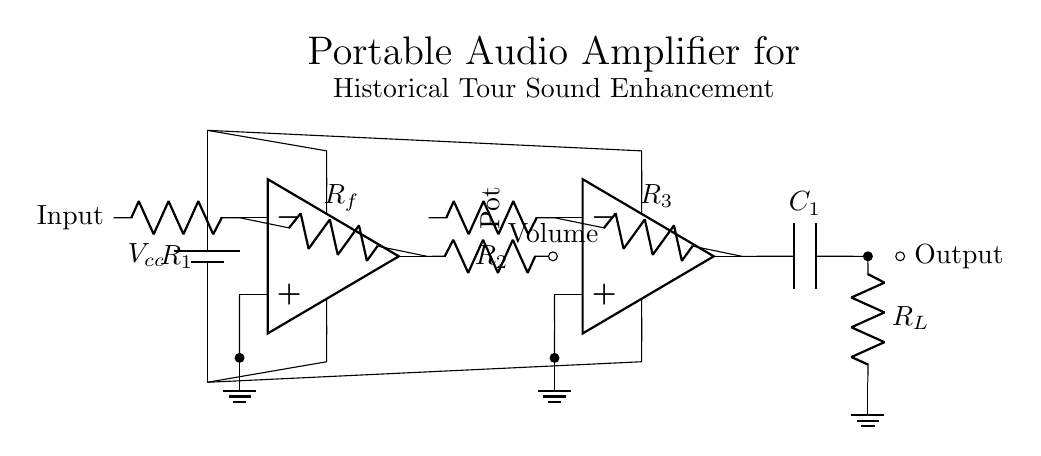What is the input component in this circuit? The input component is represented by a resistor labeled R1, which connects to the negative input of the first operational amplifier. It acts as the initial signal input for amplification.
Answer: R1 What is the value of the load resistor? The load resistor is labeled as R_L, which is placed at the output of the second operational amplifier, indicating its role in the load of the amplifier circuit.
Answer: R_L How many operational amplifiers are present in this circuit? There are two operational amplifiers shown in the diagram, each clearly labeled and connected in sequence for amplified output.
Answer: Two What purpose does the potentiometer serve in this circuit? The potentiometer, also labeled as Pot, is used to control the volume of the audio signal, allowing adjustment of the amplitude before it reaches the second amplifier stage.
Answer: Volume control What is the function of the capacitor labeled C1? The capacitor C1 is used to block any DC component of the output signal while allowing the AC audio signals to pass through to the load resistor, ensuring only the desired audio signals are amplified.
Answer: Coupling What voltage supply is used in this circuit? The circuit uses a voltage supply labeled V_cc, which is connected to the power inputs of both operational amplifiers to provide them with the necessary operating voltage.
Answer: V_cc Which stage is responsible for adjusting the sound? The volume control stage, represented by the potentiometer connected to the first operational amplifier, is responsible for allowing users to adjust the sound levels during operation.
Answer: Volume control 